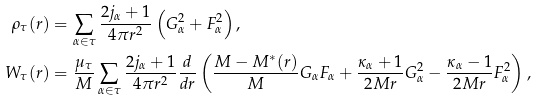<formula> <loc_0><loc_0><loc_500><loc_500>\rho _ { \tau } ( r ) & = \sum _ { \alpha \in \tau } \frac { 2 j _ { \alpha } + 1 } { 4 \pi r ^ { 2 } } \left ( G _ { \alpha } ^ { 2 } + F _ { \alpha } ^ { 2 } \right ) , \\ W _ { \tau } ( r ) & = \frac { \mu _ { \tau } } { M } \sum _ { \alpha \in \tau } \frac { 2 j _ { \alpha } + 1 } { 4 \pi r ^ { 2 } } \frac { d } { d r } \left ( \frac { M - M ^ { * } ( r ) } { M } G _ { \alpha } F _ { \alpha } + \frac { \kappa _ { \alpha } + 1 } { 2 M r } G _ { \alpha } ^ { 2 } - \frac { \kappa _ { \alpha } - 1 } { 2 M r } F _ { \alpha } ^ { 2 } \right ) ,</formula> 